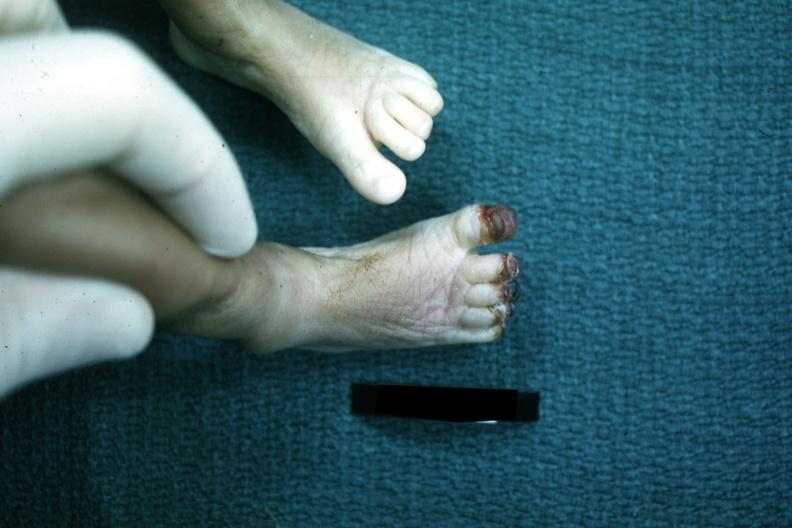s gangrene present?
Answer the question using a single word or phrase. Yes 